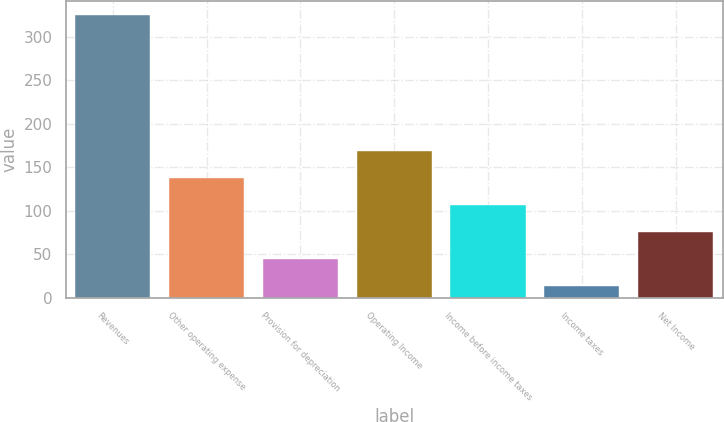Convert chart. <chart><loc_0><loc_0><loc_500><loc_500><bar_chart><fcel>Revenues<fcel>Other operating expense<fcel>Provision for depreciation<fcel>Operating Income<fcel>Income before income taxes<fcel>Income taxes<fcel>Net Income<nl><fcel>324.8<fcel>137.84<fcel>44.36<fcel>169<fcel>106.68<fcel>13.2<fcel>75.52<nl></chart> 